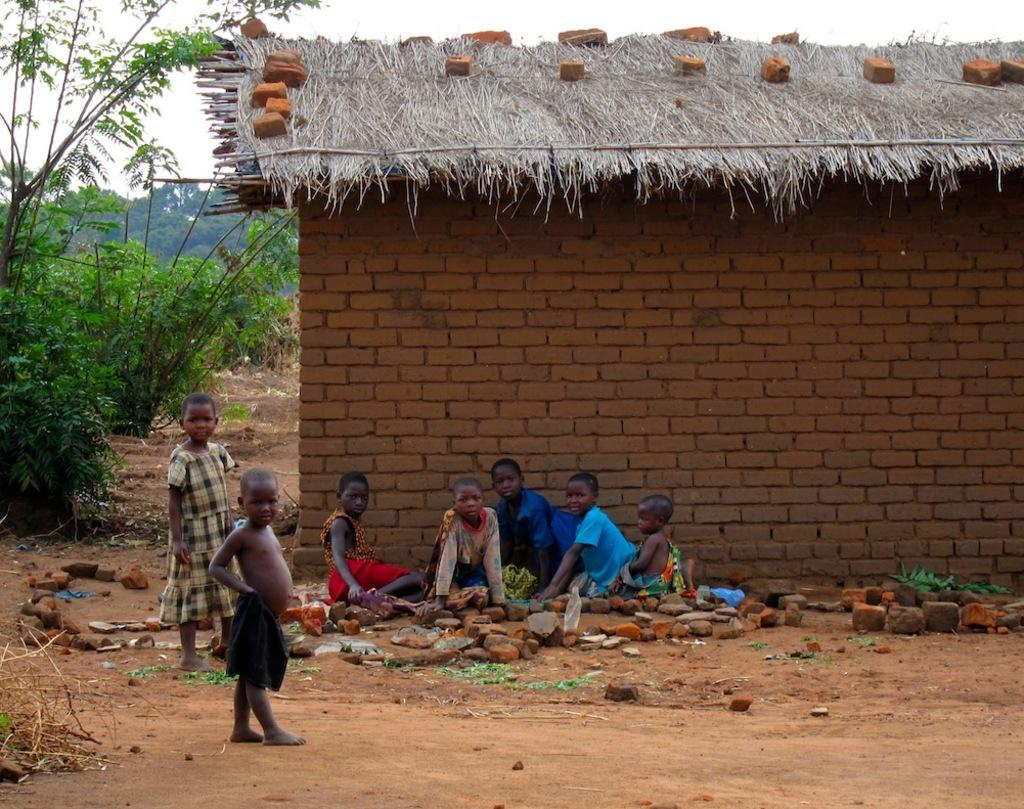How many children are present in the image? There are two children standing and five more sitting on the ground, making a total of seven children in the image. What are the children doing in the image? The children are standing and sitting on the ground. What can be seen on the ground in the image? There are stones visible in the image. What is visible in the background of the image? There is a brick house, trees, and the sky visible in the background of the image. What type of oil is being used by the children in the image? There is no oil present in the image; the children are simply standing and sitting on the ground. What shape is the dress worn by the children in the image? There is no mention of a dress in the image, as the children are not wearing any clothing that would be described as a dress. 